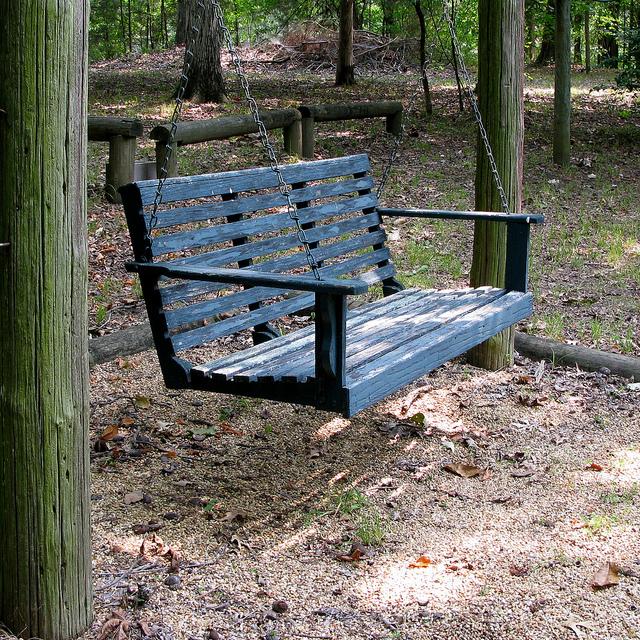What is attached to the swing holding it up?
Quick response, please. Chain. Has anyone sat there recently?
Keep it brief. No. What color is the swing?
Be succinct. Brown. Is there snow?
Answer briefly. No. 